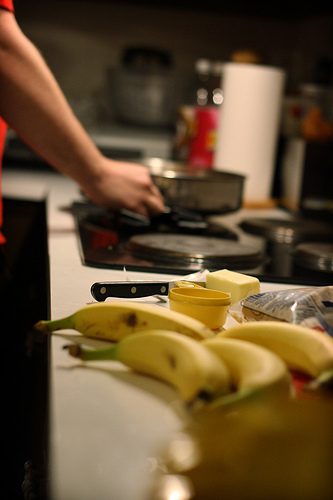On which side of the image is the bag? The bag is located on the right-hand side of the image, near other kitchen and dining utensils. 